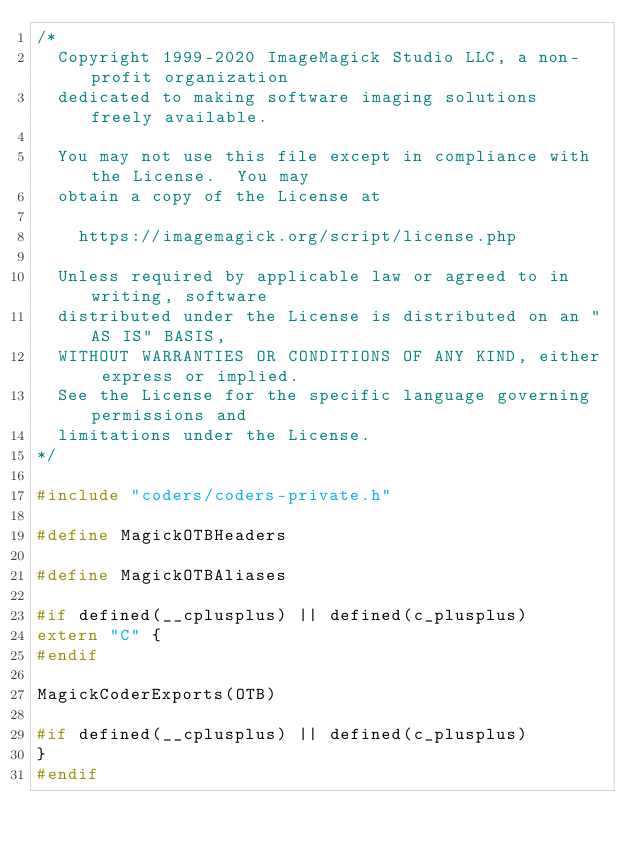<code> <loc_0><loc_0><loc_500><loc_500><_C_>/*
  Copyright 1999-2020 ImageMagick Studio LLC, a non-profit organization
  dedicated to making software imaging solutions freely available.
  
  You may not use this file except in compliance with the License.  You may
  obtain a copy of the License at
  
    https://imagemagick.org/script/license.php
  
  Unless required by applicable law or agreed to in writing, software
  distributed under the License is distributed on an "AS IS" BASIS,
  WITHOUT WARRANTIES OR CONDITIONS OF ANY KIND, either express or implied.
  See the License for the specific language governing permissions and
  limitations under the License.
*/

#include "coders/coders-private.h"

#define MagickOTBHeaders

#define MagickOTBAliases

#if defined(__cplusplus) || defined(c_plusplus)
extern "C" {
#endif

MagickCoderExports(OTB)

#if defined(__cplusplus) || defined(c_plusplus)
}
#endif</code> 